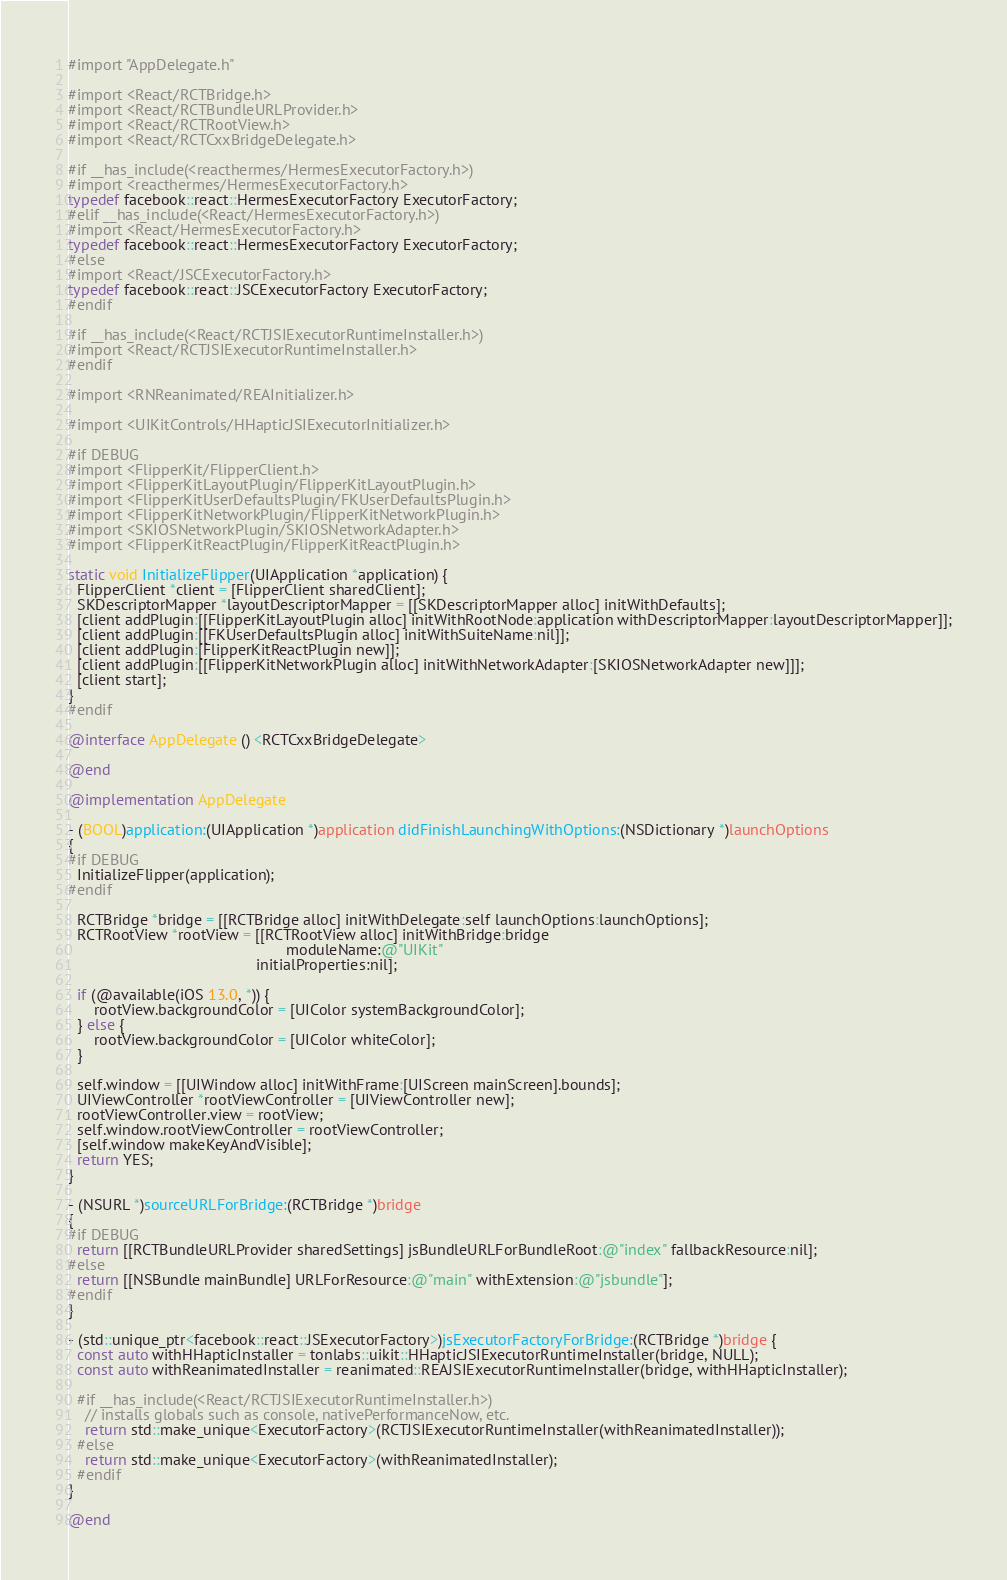Convert code to text. <code><loc_0><loc_0><loc_500><loc_500><_ObjectiveC_>#import "AppDelegate.h"

#import <React/RCTBridge.h>
#import <React/RCTBundleURLProvider.h>
#import <React/RCTRootView.h>
#import <React/RCTCxxBridgeDelegate.h>

#if __has_include(<reacthermes/HermesExecutorFactory.h>)
#import <reacthermes/HermesExecutorFactory.h>
typedef facebook::react::HermesExecutorFactory ExecutorFactory;
#elif __has_include(<React/HermesExecutorFactory.h>)
#import <React/HermesExecutorFactory.h>
typedef facebook::react::HermesExecutorFactory ExecutorFactory;
#else
#import <React/JSCExecutorFactory.h>
typedef facebook::react::JSCExecutorFactory ExecutorFactory;
#endif

#if __has_include(<React/RCTJSIExecutorRuntimeInstaller.h>)
#import <React/RCTJSIExecutorRuntimeInstaller.h>
#endif

#import <RNReanimated/REAInitializer.h>

#import <UIKitControls/HHapticJSIExecutorInitializer.h>

#if DEBUG
#import <FlipperKit/FlipperClient.h>
#import <FlipperKitLayoutPlugin/FlipperKitLayoutPlugin.h>
#import <FlipperKitUserDefaultsPlugin/FKUserDefaultsPlugin.h>
#import <FlipperKitNetworkPlugin/FlipperKitNetworkPlugin.h>
#import <SKIOSNetworkPlugin/SKIOSNetworkAdapter.h>
#import <FlipperKitReactPlugin/FlipperKitReactPlugin.h>

static void InitializeFlipper(UIApplication *application) {
  FlipperClient *client = [FlipperClient sharedClient];
  SKDescriptorMapper *layoutDescriptorMapper = [[SKDescriptorMapper alloc] initWithDefaults];
  [client addPlugin:[[FlipperKitLayoutPlugin alloc] initWithRootNode:application withDescriptorMapper:layoutDescriptorMapper]];
  [client addPlugin:[[FKUserDefaultsPlugin alloc] initWithSuiteName:nil]];
  [client addPlugin:[FlipperKitReactPlugin new]];
  [client addPlugin:[[FlipperKitNetworkPlugin alloc] initWithNetworkAdapter:[SKIOSNetworkAdapter new]]];
  [client start];
}
#endif

@interface AppDelegate () <RCTCxxBridgeDelegate>

@end

@implementation AppDelegate

- (BOOL)application:(UIApplication *)application didFinishLaunchingWithOptions:(NSDictionary *)launchOptions
{
#if DEBUG
  InitializeFlipper(application);
#endif

  RCTBridge *bridge = [[RCTBridge alloc] initWithDelegate:self launchOptions:launchOptions];
  RCTRootView *rootView = [[RCTRootView alloc] initWithBridge:bridge
                                                   moduleName:@"UIKit"
                                            initialProperties:nil];

  if (@available(iOS 13.0, *)) {
      rootView.backgroundColor = [UIColor systemBackgroundColor];
  } else {
      rootView.backgroundColor = [UIColor whiteColor];
  }

  self.window = [[UIWindow alloc] initWithFrame:[UIScreen mainScreen].bounds];
  UIViewController *rootViewController = [UIViewController new];
  rootViewController.view = rootView;
  self.window.rootViewController = rootViewController;
  [self.window makeKeyAndVisible];
  return YES;
}

- (NSURL *)sourceURLForBridge:(RCTBridge *)bridge
{
#if DEBUG
  return [[RCTBundleURLProvider sharedSettings] jsBundleURLForBundleRoot:@"index" fallbackResource:nil];
#else
  return [[NSBundle mainBundle] URLForResource:@"main" withExtension:@"jsbundle"];
#endif
}

- (std::unique_ptr<facebook::react::JSExecutorFactory>)jsExecutorFactoryForBridge:(RCTBridge *)bridge {
  const auto withHHapticInstaller = tonlabs::uikit::HHapticJSIExecutorRuntimeInstaller(bridge, NULL);
  const auto withReanimatedInstaller = reanimated::REAJSIExecutorRuntimeInstaller(bridge, withHHapticInstaller);

  #if __has_include(<React/RCTJSIExecutorRuntimeInstaller.h>)
    // installs globals such as console, nativePerformanceNow, etc.
    return std::make_unique<ExecutorFactory>(RCTJSIExecutorRuntimeInstaller(withReanimatedInstaller));
  #else
    return std::make_unique<ExecutorFactory>(withReanimatedInstaller);
  #endif
}

@end
</code> 